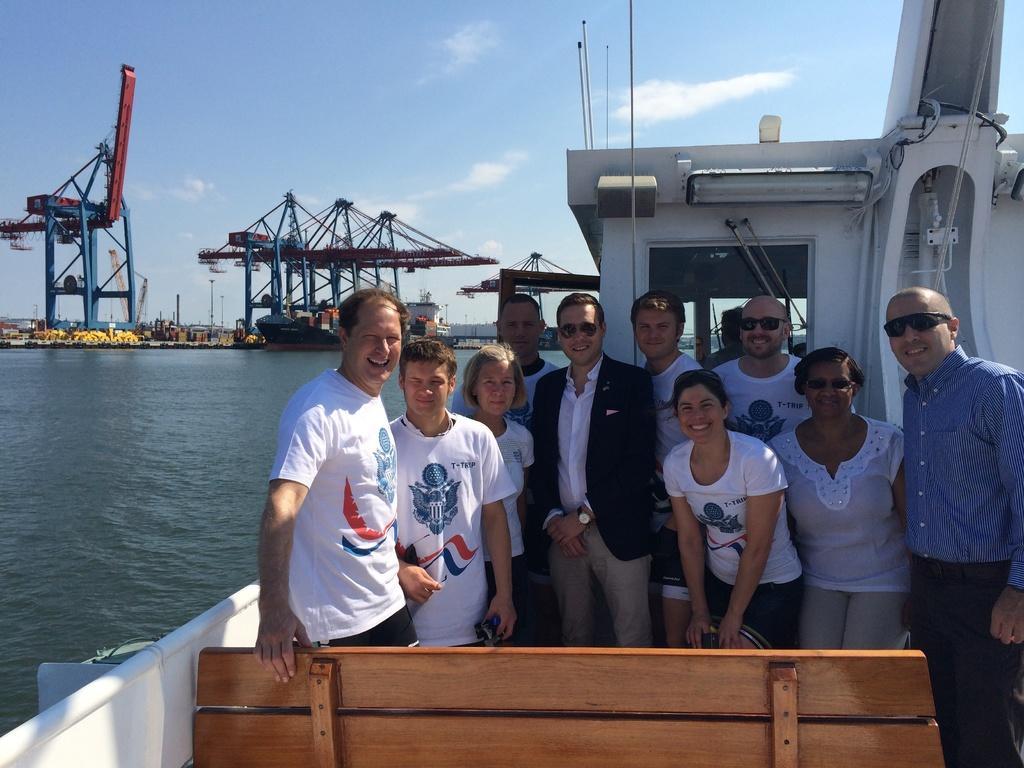Could you give a brief overview of what you see in this image? In this image there are a few people standing on the ship with a smile on their face. On the left side of the image there is a river. In the background there are a few metal structures and the sky. 